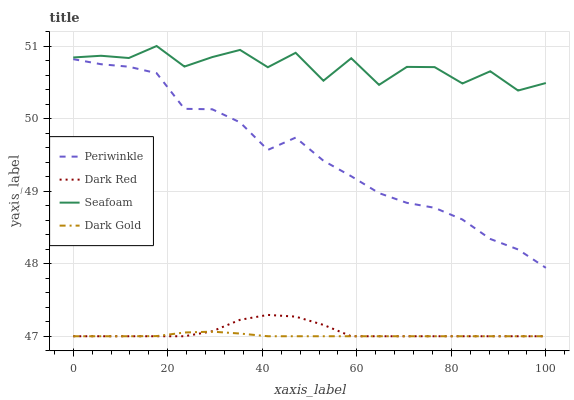Does Dark Gold have the minimum area under the curve?
Answer yes or no. Yes. Does Seafoam have the maximum area under the curve?
Answer yes or no. Yes. Does Periwinkle have the minimum area under the curve?
Answer yes or no. No. Does Periwinkle have the maximum area under the curve?
Answer yes or no. No. Is Dark Gold the smoothest?
Answer yes or no. Yes. Is Seafoam the roughest?
Answer yes or no. Yes. Is Periwinkle the smoothest?
Answer yes or no. No. Is Periwinkle the roughest?
Answer yes or no. No. Does Dark Red have the lowest value?
Answer yes or no. Yes. Does Periwinkle have the lowest value?
Answer yes or no. No. Does Seafoam have the highest value?
Answer yes or no. Yes. Does Periwinkle have the highest value?
Answer yes or no. No. Is Dark Red less than Seafoam?
Answer yes or no. Yes. Is Seafoam greater than Periwinkle?
Answer yes or no. Yes. Does Dark Gold intersect Dark Red?
Answer yes or no. Yes. Is Dark Gold less than Dark Red?
Answer yes or no. No. Is Dark Gold greater than Dark Red?
Answer yes or no. No. Does Dark Red intersect Seafoam?
Answer yes or no. No. 